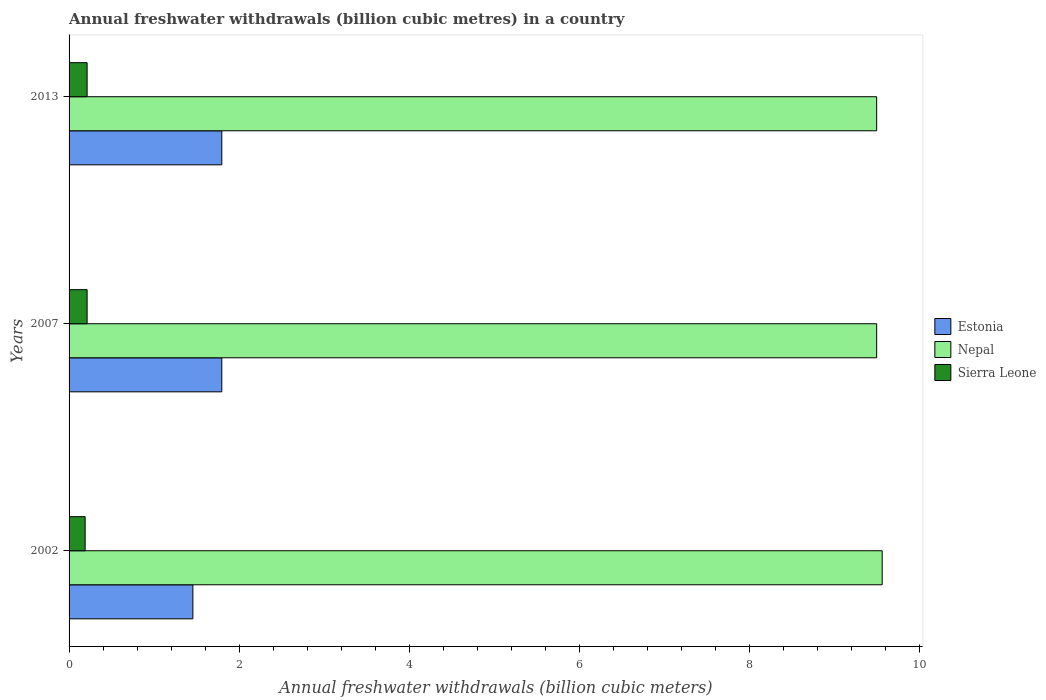Are the number of bars per tick equal to the number of legend labels?
Provide a short and direct response. Yes. Are the number of bars on each tick of the Y-axis equal?
Offer a very short reply. Yes. How many bars are there on the 3rd tick from the bottom?
Ensure brevity in your answer.  3. What is the annual freshwater withdrawals in Nepal in 2002?
Provide a succinct answer. 9.56. Across all years, what is the maximum annual freshwater withdrawals in Sierra Leone?
Keep it short and to the point. 0.21. Across all years, what is the minimum annual freshwater withdrawals in Nepal?
Provide a succinct answer. 9.5. In which year was the annual freshwater withdrawals in Nepal minimum?
Provide a succinct answer. 2007. What is the total annual freshwater withdrawals in Estonia in the graph?
Provide a short and direct response. 5.05. What is the difference between the annual freshwater withdrawals in Estonia in 2013 and the annual freshwater withdrawals in Nepal in 2007?
Make the answer very short. -7.7. What is the average annual freshwater withdrawals in Sierra Leone per year?
Provide a short and direct response. 0.2. In the year 2007, what is the difference between the annual freshwater withdrawals in Sierra Leone and annual freshwater withdrawals in Estonia?
Your answer should be compact. -1.58. What is the ratio of the annual freshwater withdrawals in Sierra Leone in 2002 to that in 2013?
Your answer should be very brief. 0.89. What is the difference between the highest and the second highest annual freshwater withdrawals in Nepal?
Your response must be concise. 0.06. What is the difference between the highest and the lowest annual freshwater withdrawals in Sierra Leone?
Provide a short and direct response. 0.02. What does the 2nd bar from the top in 2013 represents?
Your answer should be compact. Nepal. What does the 2nd bar from the bottom in 2013 represents?
Offer a very short reply. Nepal. Is it the case that in every year, the sum of the annual freshwater withdrawals in Nepal and annual freshwater withdrawals in Sierra Leone is greater than the annual freshwater withdrawals in Estonia?
Offer a terse response. Yes. How many bars are there?
Your answer should be compact. 9. Are all the bars in the graph horizontal?
Offer a very short reply. Yes. What is the difference between two consecutive major ticks on the X-axis?
Your response must be concise. 2. Are the values on the major ticks of X-axis written in scientific E-notation?
Your answer should be very brief. No. Does the graph contain any zero values?
Ensure brevity in your answer.  No. Where does the legend appear in the graph?
Your answer should be compact. Center right. How are the legend labels stacked?
Your response must be concise. Vertical. What is the title of the graph?
Ensure brevity in your answer.  Annual freshwater withdrawals (billion cubic metres) in a country. Does "Armenia" appear as one of the legend labels in the graph?
Offer a terse response. No. What is the label or title of the X-axis?
Offer a terse response. Annual freshwater withdrawals (billion cubic meters). What is the Annual freshwater withdrawals (billion cubic meters) in Estonia in 2002?
Offer a terse response. 1.46. What is the Annual freshwater withdrawals (billion cubic meters) in Nepal in 2002?
Keep it short and to the point. 9.56. What is the Annual freshwater withdrawals (billion cubic meters) of Sierra Leone in 2002?
Your answer should be very brief. 0.19. What is the Annual freshwater withdrawals (billion cubic meters) of Estonia in 2007?
Your answer should be very brief. 1.8. What is the Annual freshwater withdrawals (billion cubic meters) of Nepal in 2007?
Make the answer very short. 9.5. What is the Annual freshwater withdrawals (billion cubic meters) in Sierra Leone in 2007?
Ensure brevity in your answer.  0.21. What is the Annual freshwater withdrawals (billion cubic meters) of Estonia in 2013?
Your answer should be very brief. 1.8. What is the Annual freshwater withdrawals (billion cubic meters) of Nepal in 2013?
Your response must be concise. 9.5. What is the Annual freshwater withdrawals (billion cubic meters) of Sierra Leone in 2013?
Make the answer very short. 0.21. Across all years, what is the maximum Annual freshwater withdrawals (billion cubic meters) of Estonia?
Give a very brief answer. 1.8. Across all years, what is the maximum Annual freshwater withdrawals (billion cubic meters) of Nepal?
Ensure brevity in your answer.  9.56. Across all years, what is the maximum Annual freshwater withdrawals (billion cubic meters) in Sierra Leone?
Offer a very short reply. 0.21. Across all years, what is the minimum Annual freshwater withdrawals (billion cubic meters) in Estonia?
Your answer should be compact. 1.46. Across all years, what is the minimum Annual freshwater withdrawals (billion cubic meters) of Nepal?
Your response must be concise. 9.5. Across all years, what is the minimum Annual freshwater withdrawals (billion cubic meters) in Sierra Leone?
Provide a succinct answer. 0.19. What is the total Annual freshwater withdrawals (billion cubic meters) of Estonia in the graph?
Offer a terse response. 5.05. What is the total Annual freshwater withdrawals (billion cubic meters) of Nepal in the graph?
Ensure brevity in your answer.  28.56. What is the total Annual freshwater withdrawals (billion cubic meters) in Sierra Leone in the graph?
Your response must be concise. 0.61. What is the difference between the Annual freshwater withdrawals (billion cubic meters) of Estonia in 2002 and that in 2007?
Your answer should be very brief. -0.34. What is the difference between the Annual freshwater withdrawals (billion cubic meters) in Nepal in 2002 and that in 2007?
Give a very brief answer. 0.07. What is the difference between the Annual freshwater withdrawals (billion cubic meters) of Sierra Leone in 2002 and that in 2007?
Ensure brevity in your answer.  -0.02. What is the difference between the Annual freshwater withdrawals (billion cubic meters) of Estonia in 2002 and that in 2013?
Ensure brevity in your answer.  -0.34. What is the difference between the Annual freshwater withdrawals (billion cubic meters) of Nepal in 2002 and that in 2013?
Provide a short and direct response. 0.07. What is the difference between the Annual freshwater withdrawals (billion cubic meters) of Sierra Leone in 2002 and that in 2013?
Make the answer very short. -0.02. What is the difference between the Annual freshwater withdrawals (billion cubic meters) of Nepal in 2007 and that in 2013?
Your answer should be compact. 0. What is the difference between the Annual freshwater withdrawals (billion cubic meters) of Estonia in 2002 and the Annual freshwater withdrawals (billion cubic meters) of Nepal in 2007?
Ensure brevity in your answer.  -8.04. What is the difference between the Annual freshwater withdrawals (billion cubic meters) in Estonia in 2002 and the Annual freshwater withdrawals (billion cubic meters) in Sierra Leone in 2007?
Offer a terse response. 1.24. What is the difference between the Annual freshwater withdrawals (billion cubic meters) of Nepal in 2002 and the Annual freshwater withdrawals (billion cubic meters) of Sierra Leone in 2007?
Keep it short and to the point. 9.35. What is the difference between the Annual freshwater withdrawals (billion cubic meters) of Estonia in 2002 and the Annual freshwater withdrawals (billion cubic meters) of Nepal in 2013?
Ensure brevity in your answer.  -8.04. What is the difference between the Annual freshwater withdrawals (billion cubic meters) of Estonia in 2002 and the Annual freshwater withdrawals (billion cubic meters) of Sierra Leone in 2013?
Your answer should be very brief. 1.24. What is the difference between the Annual freshwater withdrawals (billion cubic meters) of Nepal in 2002 and the Annual freshwater withdrawals (billion cubic meters) of Sierra Leone in 2013?
Keep it short and to the point. 9.35. What is the difference between the Annual freshwater withdrawals (billion cubic meters) of Estonia in 2007 and the Annual freshwater withdrawals (billion cubic meters) of Nepal in 2013?
Your answer should be compact. -7.7. What is the difference between the Annual freshwater withdrawals (billion cubic meters) in Estonia in 2007 and the Annual freshwater withdrawals (billion cubic meters) in Sierra Leone in 2013?
Offer a terse response. 1.58. What is the difference between the Annual freshwater withdrawals (billion cubic meters) of Nepal in 2007 and the Annual freshwater withdrawals (billion cubic meters) of Sierra Leone in 2013?
Ensure brevity in your answer.  9.28. What is the average Annual freshwater withdrawals (billion cubic meters) of Estonia per year?
Offer a very short reply. 1.68. What is the average Annual freshwater withdrawals (billion cubic meters) in Nepal per year?
Give a very brief answer. 9.52. What is the average Annual freshwater withdrawals (billion cubic meters) of Sierra Leone per year?
Your answer should be compact. 0.2. In the year 2002, what is the difference between the Annual freshwater withdrawals (billion cubic meters) in Estonia and Annual freshwater withdrawals (billion cubic meters) in Nepal?
Your response must be concise. -8.11. In the year 2002, what is the difference between the Annual freshwater withdrawals (billion cubic meters) in Estonia and Annual freshwater withdrawals (billion cubic meters) in Sierra Leone?
Provide a short and direct response. 1.27. In the year 2002, what is the difference between the Annual freshwater withdrawals (billion cubic meters) of Nepal and Annual freshwater withdrawals (billion cubic meters) of Sierra Leone?
Your answer should be very brief. 9.37. In the year 2007, what is the difference between the Annual freshwater withdrawals (billion cubic meters) of Estonia and Annual freshwater withdrawals (billion cubic meters) of Nepal?
Make the answer very short. -7.7. In the year 2007, what is the difference between the Annual freshwater withdrawals (billion cubic meters) of Estonia and Annual freshwater withdrawals (billion cubic meters) of Sierra Leone?
Your answer should be very brief. 1.58. In the year 2007, what is the difference between the Annual freshwater withdrawals (billion cubic meters) in Nepal and Annual freshwater withdrawals (billion cubic meters) in Sierra Leone?
Offer a terse response. 9.28. In the year 2013, what is the difference between the Annual freshwater withdrawals (billion cubic meters) in Estonia and Annual freshwater withdrawals (billion cubic meters) in Nepal?
Give a very brief answer. -7.7. In the year 2013, what is the difference between the Annual freshwater withdrawals (billion cubic meters) in Estonia and Annual freshwater withdrawals (billion cubic meters) in Sierra Leone?
Your response must be concise. 1.58. In the year 2013, what is the difference between the Annual freshwater withdrawals (billion cubic meters) in Nepal and Annual freshwater withdrawals (billion cubic meters) in Sierra Leone?
Your response must be concise. 9.28. What is the ratio of the Annual freshwater withdrawals (billion cubic meters) in Estonia in 2002 to that in 2007?
Provide a succinct answer. 0.81. What is the ratio of the Annual freshwater withdrawals (billion cubic meters) of Nepal in 2002 to that in 2007?
Make the answer very short. 1.01. What is the ratio of the Annual freshwater withdrawals (billion cubic meters) in Sierra Leone in 2002 to that in 2007?
Your answer should be compact. 0.89. What is the ratio of the Annual freshwater withdrawals (billion cubic meters) of Estonia in 2002 to that in 2013?
Offer a terse response. 0.81. What is the ratio of the Annual freshwater withdrawals (billion cubic meters) of Nepal in 2002 to that in 2013?
Make the answer very short. 1.01. What is the ratio of the Annual freshwater withdrawals (billion cubic meters) of Sierra Leone in 2002 to that in 2013?
Make the answer very short. 0.89. What is the ratio of the Annual freshwater withdrawals (billion cubic meters) of Estonia in 2007 to that in 2013?
Offer a terse response. 1. What is the ratio of the Annual freshwater withdrawals (billion cubic meters) in Nepal in 2007 to that in 2013?
Give a very brief answer. 1. What is the difference between the highest and the second highest Annual freshwater withdrawals (billion cubic meters) of Estonia?
Your answer should be compact. 0. What is the difference between the highest and the second highest Annual freshwater withdrawals (billion cubic meters) of Nepal?
Offer a very short reply. 0.07. What is the difference between the highest and the second highest Annual freshwater withdrawals (billion cubic meters) in Sierra Leone?
Ensure brevity in your answer.  0. What is the difference between the highest and the lowest Annual freshwater withdrawals (billion cubic meters) in Estonia?
Make the answer very short. 0.34. What is the difference between the highest and the lowest Annual freshwater withdrawals (billion cubic meters) of Nepal?
Your response must be concise. 0.07. What is the difference between the highest and the lowest Annual freshwater withdrawals (billion cubic meters) in Sierra Leone?
Keep it short and to the point. 0.02. 